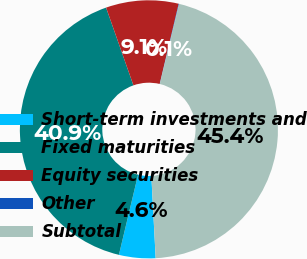<chart> <loc_0><loc_0><loc_500><loc_500><pie_chart><fcel>Short-term investments and<fcel>Fixed maturities<fcel>Equity securities<fcel>Other<fcel>Subtotal<nl><fcel>4.57%<fcel>40.88%<fcel>9.09%<fcel>0.06%<fcel>45.4%<nl></chart> 